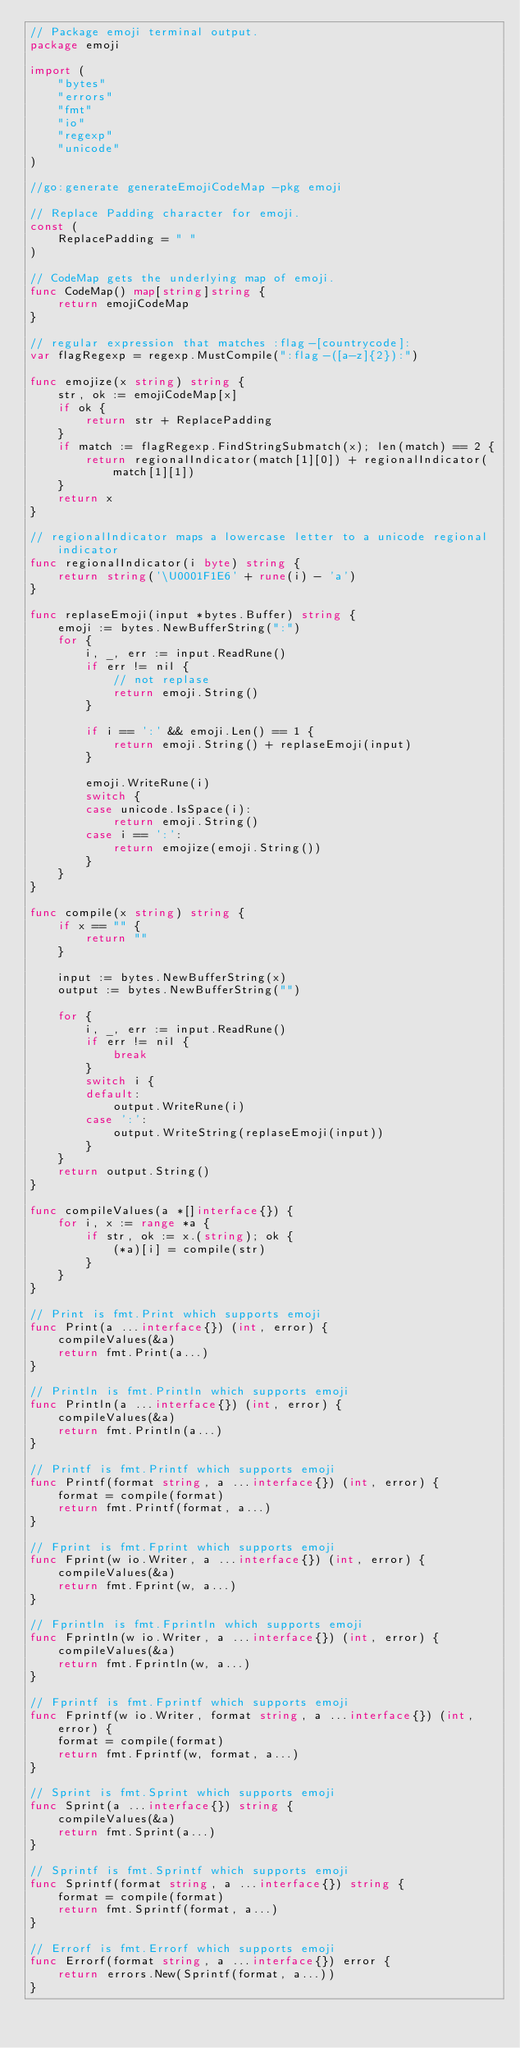<code> <loc_0><loc_0><loc_500><loc_500><_Go_>// Package emoji terminal output.
package emoji

import (
	"bytes"
	"errors"
	"fmt"
	"io"
	"regexp"
	"unicode"
)

//go:generate generateEmojiCodeMap -pkg emoji

// Replace Padding character for emoji.
const (
	ReplacePadding = " "
)

// CodeMap gets the underlying map of emoji.
func CodeMap() map[string]string {
	return emojiCodeMap
}

// regular expression that matches :flag-[countrycode]:
var flagRegexp = regexp.MustCompile(":flag-([a-z]{2}):")

func emojize(x string) string {
	str, ok := emojiCodeMap[x]
	if ok {
		return str + ReplacePadding
	}
	if match := flagRegexp.FindStringSubmatch(x); len(match) == 2 {
		return regionalIndicator(match[1][0]) + regionalIndicator(match[1][1])
	}
	return x
}

// regionalIndicator maps a lowercase letter to a unicode regional indicator
func regionalIndicator(i byte) string {
	return string('\U0001F1E6' + rune(i) - 'a')
}

func replaseEmoji(input *bytes.Buffer) string {
	emoji := bytes.NewBufferString(":")
	for {
		i, _, err := input.ReadRune()
		if err != nil {
			// not replase
			return emoji.String()
		}

		if i == ':' && emoji.Len() == 1 {
			return emoji.String() + replaseEmoji(input)
		}

		emoji.WriteRune(i)
		switch {
		case unicode.IsSpace(i):
			return emoji.String()
		case i == ':':
			return emojize(emoji.String())
		}
	}
}

func compile(x string) string {
	if x == "" {
		return ""
	}

	input := bytes.NewBufferString(x)
	output := bytes.NewBufferString("")

	for {
		i, _, err := input.ReadRune()
		if err != nil {
			break
		}
		switch i {
		default:
			output.WriteRune(i)
		case ':':
			output.WriteString(replaseEmoji(input))
		}
	}
	return output.String()
}

func compileValues(a *[]interface{}) {
	for i, x := range *a {
		if str, ok := x.(string); ok {
			(*a)[i] = compile(str)
		}
	}
}

// Print is fmt.Print which supports emoji
func Print(a ...interface{}) (int, error) {
	compileValues(&a)
	return fmt.Print(a...)
}

// Println is fmt.Println which supports emoji
func Println(a ...interface{}) (int, error) {
	compileValues(&a)
	return fmt.Println(a...)
}

// Printf is fmt.Printf which supports emoji
func Printf(format string, a ...interface{}) (int, error) {
	format = compile(format)
	return fmt.Printf(format, a...)
}

// Fprint is fmt.Fprint which supports emoji
func Fprint(w io.Writer, a ...interface{}) (int, error) {
	compileValues(&a)
	return fmt.Fprint(w, a...)
}

// Fprintln is fmt.Fprintln which supports emoji
func Fprintln(w io.Writer, a ...interface{}) (int, error) {
	compileValues(&a)
	return fmt.Fprintln(w, a...)
}

// Fprintf is fmt.Fprintf which supports emoji
func Fprintf(w io.Writer, format string, a ...interface{}) (int, error) {
	format = compile(format)
	return fmt.Fprintf(w, format, a...)
}

// Sprint is fmt.Sprint which supports emoji
func Sprint(a ...interface{}) string {
	compileValues(&a)
	return fmt.Sprint(a...)
}

// Sprintf is fmt.Sprintf which supports emoji
func Sprintf(format string, a ...interface{}) string {
	format = compile(format)
	return fmt.Sprintf(format, a...)
}

// Errorf is fmt.Errorf which supports emoji
func Errorf(format string, a ...interface{}) error {
	return errors.New(Sprintf(format, a...))
}
</code> 